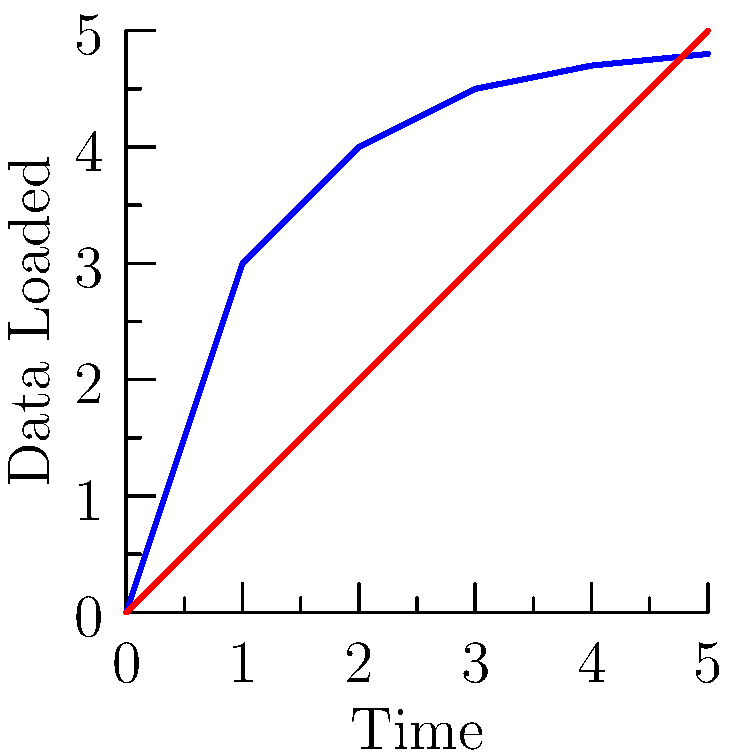Based on the diagram comparing eager loading and lazy loading strategies for Ember.js data fetching, which approach would be more suitable for an application with a large initial dataset but infrequent subsequent data requests? To determine the most suitable approach, let's analyze the diagram and consider the characteristics of each strategy:

1. Eager Loading (Blue Line):
   - Loads a large amount of data upfront
   - Steep initial curve, indicating rapid data loading at the beginning
   - Flattens out over time, showing little additional data loading

2. Lazy Loading (Red Line):
   - Starts with minimal data loading
   - Linear increase over time, indicating consistent data loading as needed

3. Application Requirements:
   - Large initial dataset
   - Infrequent subsequent data requests

4. Analysis:
   - Eager loading is better suited for loading large amounts of data upfront
   - The flat curve after initial loading aligns with infrequent subsequent requests
   - Lazy loading would result in slower initial load times and unnecessary loading during infrequent requests

5. Conclusion:
   Eager loading is more suitable for this scenario as it quickly loads the large initial dataset and minimizes subsequent data fetching, aligning with the infrequent nature of future requests.
Answer: Eager loading 